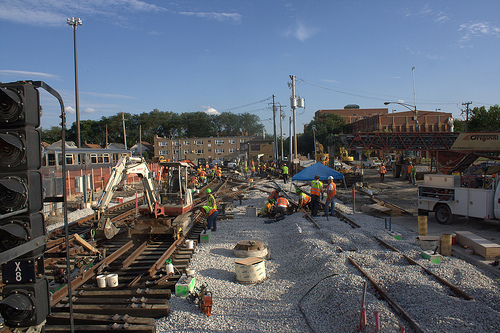<image>
Is there a excavator on the railway? Yes. Looking at the image, I can see the excavator is positioned on top of the railway, with the railway providing support. 